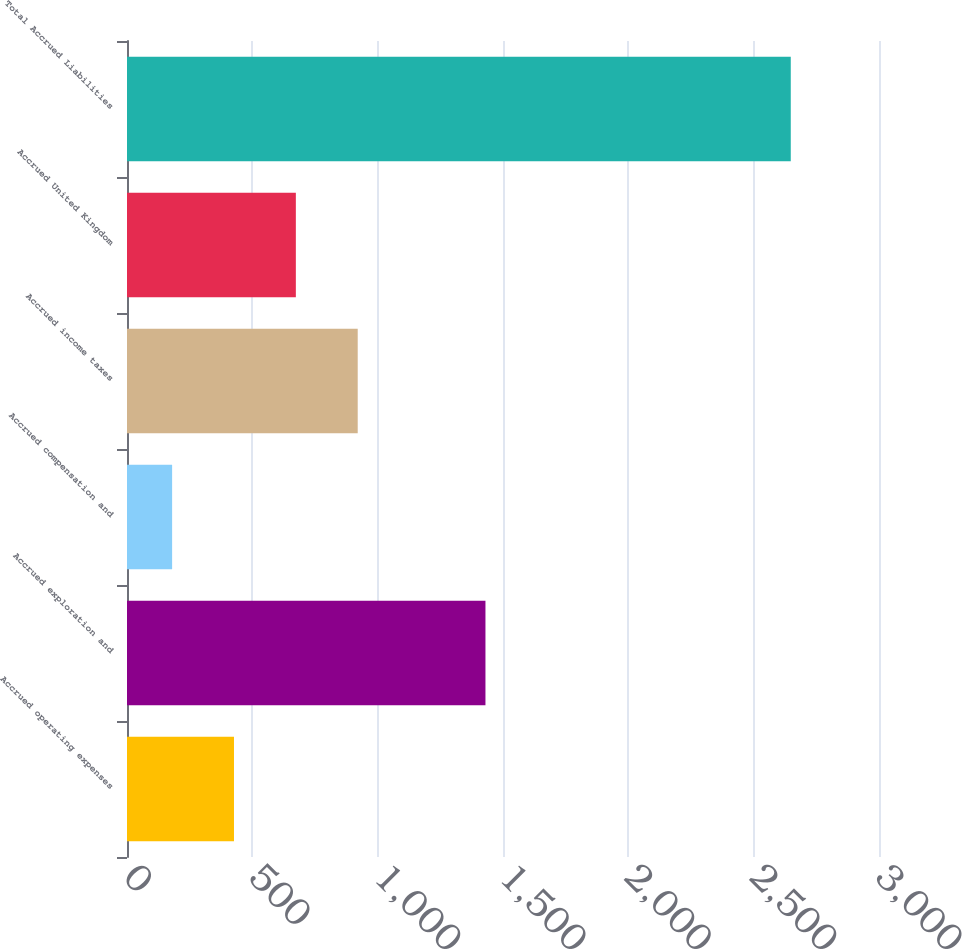Convert chart. <chart><loc_0><loc_0><loc_500><loc_500><bar_chart><fcel>Accrued operating expenses<fcel>Accrued exploration and<fcel>Accrued compensation and<fcel>Accrued income taxes<fcel>Accrued United Kingdom<fcel>Total Accrued Liabilities<nl><fcel>426.8<fcel>1430<fcel>180<fcel>920.4<fcel>673.6<fcel>2648<nl></chart> 